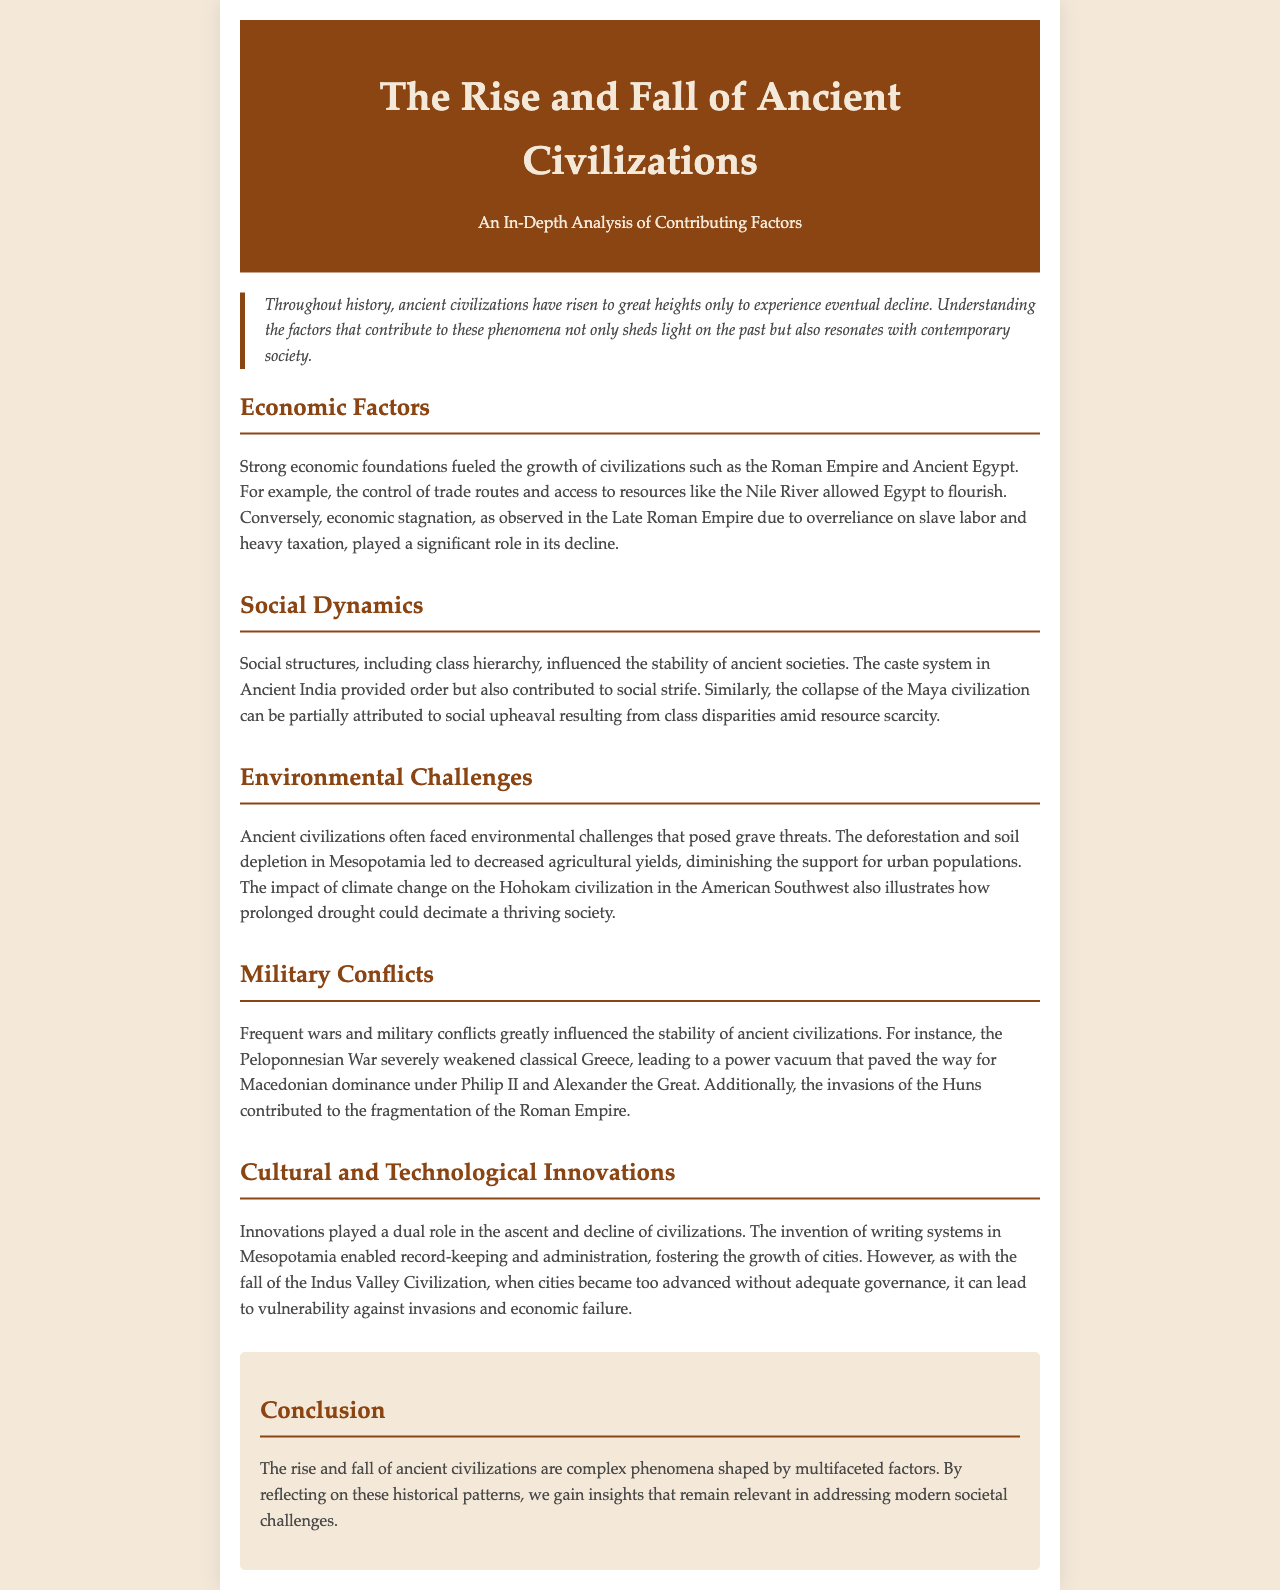What are the two main themes discussed in the newsletter? The newsletter discusses **Economic Factors** and **Social Dynamics** among other factors contributing to the rise and fall of civilizations.
Answer: Economic Factors, Social Dynamics Which civilization is mentioned as having flourished due to its control of trade routes? The document states that **Ancient Egypt** flourished due to the control of trade routes and access to resources like the Nile River.
Answer: Ancient Egypt What significant war is mentioned that weakened classical Greece? The newsletter discusses the **Peloponnesian War** as a significant conflict that weakened classical Greece.
Answer: Peloponnesian War What environmental challenge contributed to the decline of the Hohokam civilization? Prolonged **drought** is mentioned as an environmental challenge that decimated the Hohokam civilization in the American Southwest.
Answer: drought Which ancient civilization's collapse was partially attributed to social upheaval? The newsletter states that the **Maya civilization** experienced collapse due to social upheaval amid resource scarcity.
Answer: Maya civilization What invention is noted for its role in fostering the growth of cities in Mesopotamia? The newsletter highlights the **invention of writing systems** in Mesopotamia as a crucial innovation for city growth.
Answer: invention of writing systems What is the concluding theme of the newsletter? The conclusion emphasizes the complex phenomena shaped by **multifaceted factors** that influence the rise and fall of civilizations.
Answer: multifaceted factors What type of governance issue contributed to the fall of the Indus Valley Civilization? The newsletter indicates that **inadequate governance** contributed to the fall of the Indus Valley Civilization amid advancements.
Answer: inadequate governance Which empire's fragmentation was influenced by Huns’ invasions? The document mentions the **Roman Empire** as being fragmented due to invasions by the Huns.
Answer: Roman Empire 